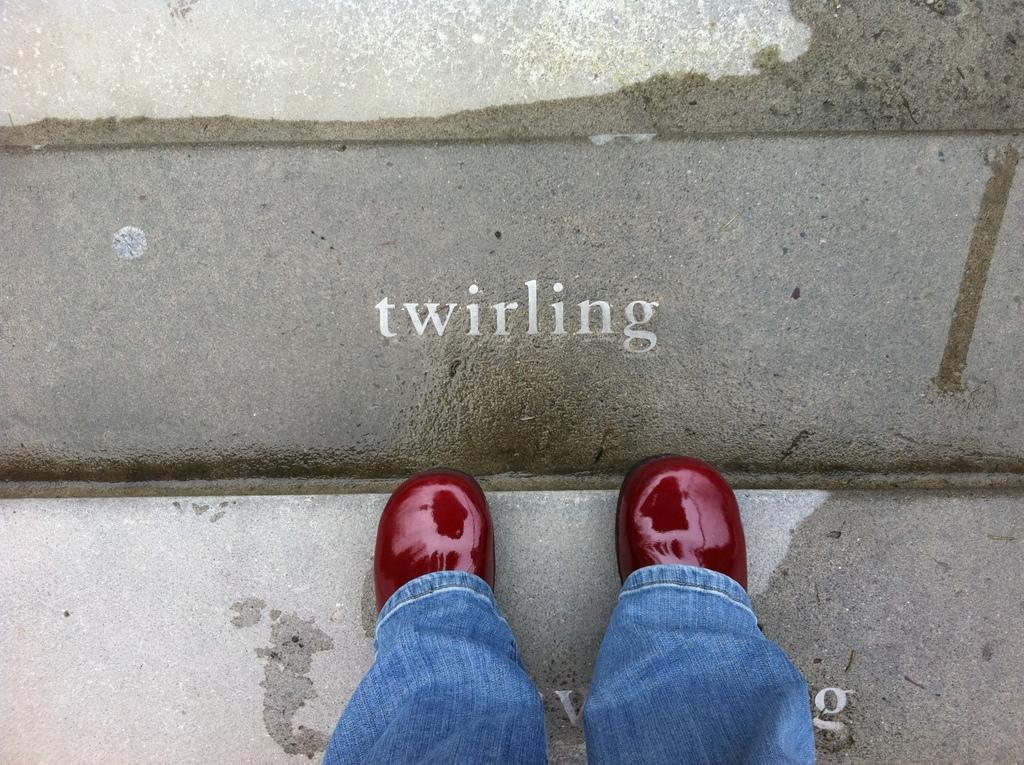How would you summarize this image in a sentence or two? In this picture there are two legs at the bottom side of the image, on the stair. 